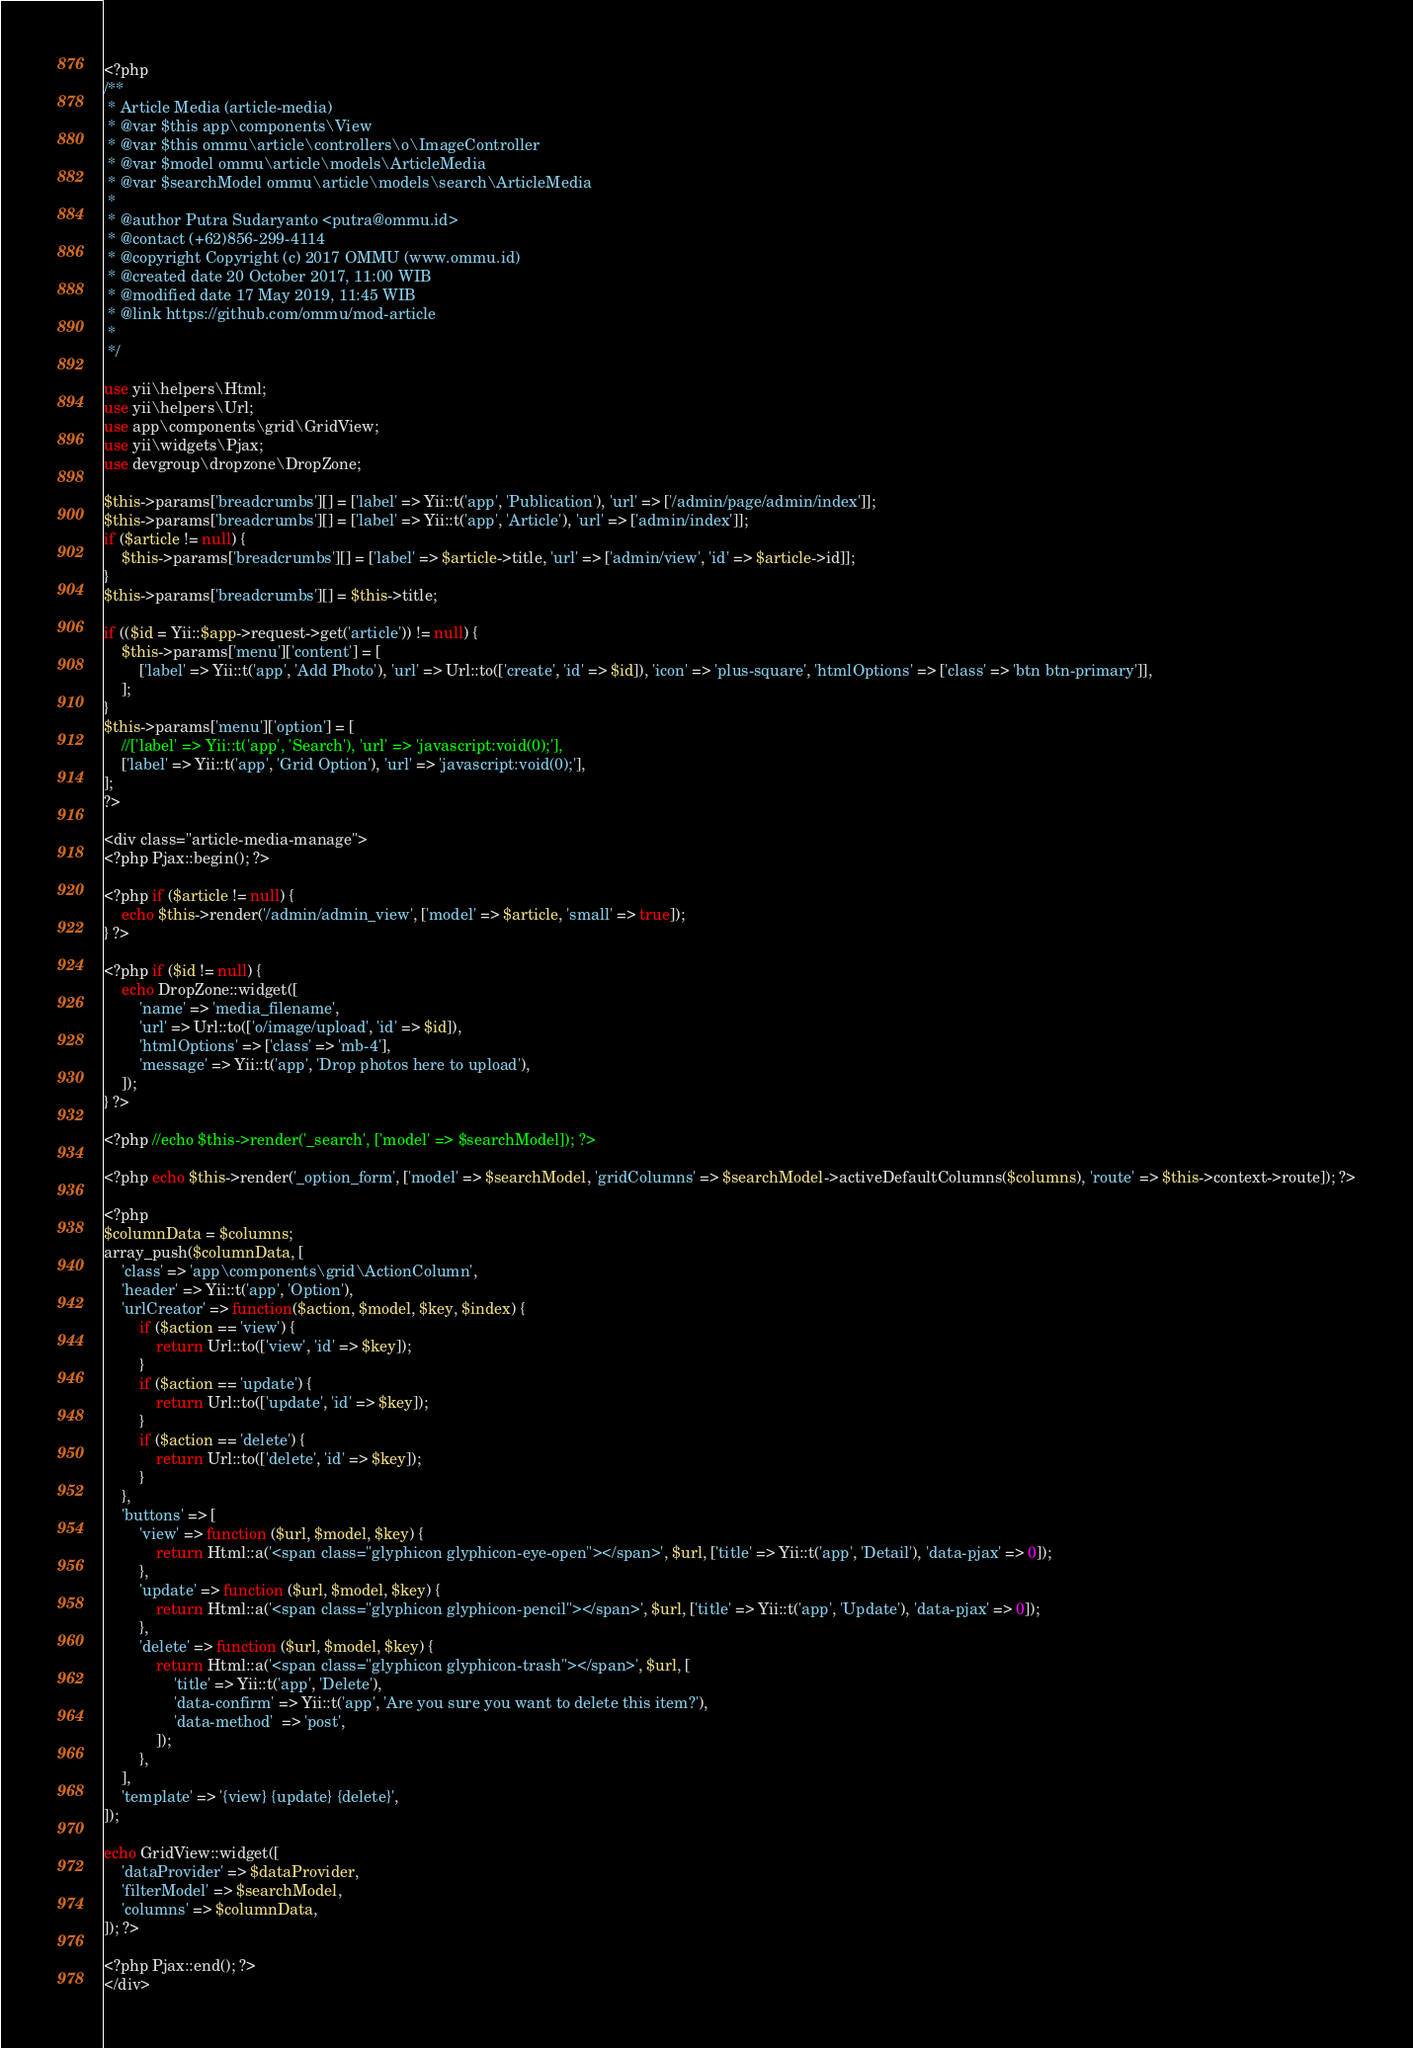Convert code to text. <code><loc_0><loc_0><loc_500><loc_500><_PHP_><?php
/**
 * Article Media (article-media)
 * @var $this app\components\View
 * @var $this ommu\article\controllers\o\ImageController
 * @var $model ommu\article\models\ArticleMedia
 * @var $searchModel ommu\article\models\search\ArticleMedia
 *
 * @author Putra Sudaryanto <putra@ommu.id>
 * @contact (+62)856-299-4114
 * @copyright Copyright (c) 2017 OMMU (www.ommu.id)
 * @created date 20 October 2017, 11:00 WIB
 * @modified date 17 May 2019, 11:45 WIB
 * @link https://github.com/ommu/mod-article
 *
 */

use yii\helpers\Html;
use yii\helpers\Url;
use app\components\grid\GridView;
use yii\widgets\Pjax;
use devgroup\dropzone\DropZone;

$this->params['breadcrumbs'][] = ['label' => Yii::t('app', 'Publication'), 'url' => ['/admin/page/admin/index']];
$this->params['breadcrumbs'][] = ['label' => Yii::t('app', 'Article'), 'url' => ['admin/index']];
if ($article != null) {
    $this->params['breadcrumbs'][] = ['label' => $article->title, 'url' => ['admin/view', 'id' => $article->id]];
}
$this->params['breadcrumbs'][] = $this->title;

if (($id = Yii::$app->request->get('article')) != null) {
	$this->params['menu']['content'] = [
		['label' => Yii::t('app', 'Add Photo'), 'url' => Url::to(['create', 'id' => $id]), 'icon' => 'plus-square', 'htmlOptions' => ['class' => 'btn btn-primary']],
	];
}
$this->params['menu']['option'] = [
	//['label' => Yii::t('app', 'Search'), 'url' => 'javascript:void(0);'],
	['label' => Yii::t('app', 'Grid Option'), 'url' => 'javascript:void(0);'],
];
?>

<div class="article-media-manage">
<?php Pjax::begin(); ?>

<?php if ($article != null) {
	echo $this->render('/admin/admin_view', ['model' => $article, 'small' => true]);
} ?>

<?php if ($id != null) {
	echo DropZone::widget([
		'name' => 'media_filename',
		'url' => Url::to(['o/image/upload', 'id' => $id]),
		'htmlOptions' => ['class' => 'mb-4'],
		'message' => Yii::t('app', 'Drop photos here to upload'),
	]);
} ?>

<?php //echo $this->render('_search', ['model' => $searchModel]); ?>

<?php echo $this->render('_option_form', ['model' => $searchModel, 'gridColumns' => $searchModel->activeDefaultColumns($columns), 'route' => $this->context->route]); ?>

<?php
$columnData = $columns;
array_push($columnData, [
	'class' => 'app\components\grid\ActionColumn',
	'header' => Yii::t('app', 'Option'),
	'urlCreator' => function($action, $model, $key, $index) {
        if ($action == 'view') {
            return Url::to(['view', 'id' => $key]);
        }
        if ($action == 'update') {
            return Url::to(['update', 'id' => $key]);
        }
        if ($action == 'delete') {
            return Url::to(['delete', 'id' => $key]);
        }
	},
	'buttons' => [
		'view' => function ($url, $model, $key) {
			return Html::a('<span class="glyphicon glyphicon-eye-open"></span>', $url, ['title' => Yii::t('app', 'Detail'), 'data-pjax' => 0]);
		},
		'update' => function ($url, $model, $key) {
			return Html::a('<span class="glyphicon glyphicon-pencil"></span>', $url, ['title' => Yii::t('app', 'Update'), 'data-pjax' => 0]);
		},
		'delete' => function ($url, $model, $key) {
			return Html::a('<span class="glyphicon glyphicon-trash"></span>', $url, [
				'title' => Yii::t('app', 'Delete'),
				'data-confirm' => Yii::t('app', 'Are you sure you want to delete this item?'),
				'data-method'  => 'post',
			]);
		},
	],
	'template' => '{view} {update} {delete}',
]);

echo GridView::widget([
	'dataProvider' => $dataProvider,
	'filterModel' => $searchModel,
	'columns' => $columnData,
]); ?>

<?php Pjax::end(); ?>
</div></code> 